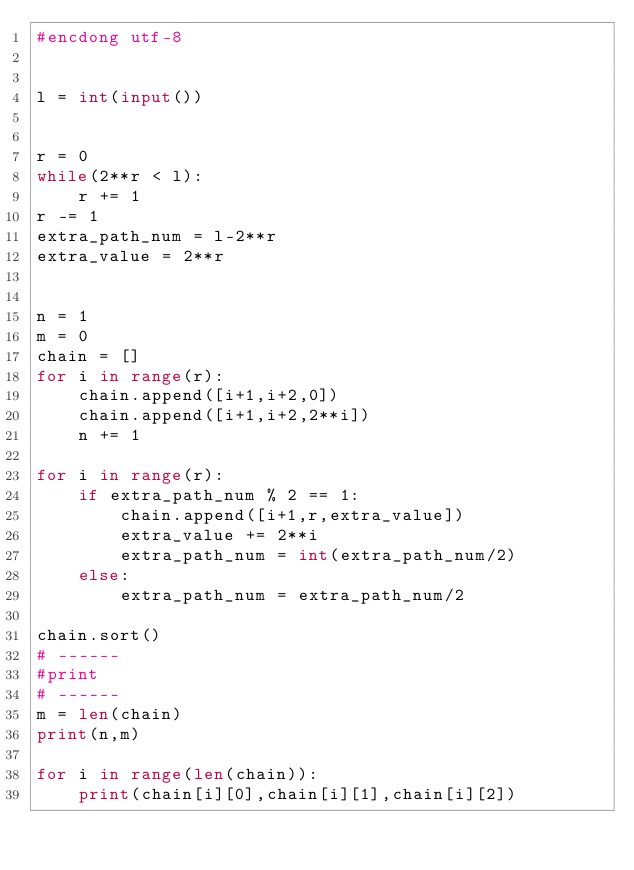Convert code to text. <code><loc_0><loc_0><loc_500><loc_500><_Python_>#encdong utf-8


l = int(input())


r = 0
while(2**r < l):
    r += 1
r -= 1
extra_path_num = l-2**r
extra_value = 2**r


n = 1
m = 0
chain = []
for i in range(r):
    chain.append([i+1,i+2,0])
    chain.append([i+1,i+2,2**i])
    n += 1

for i in range(r):
    if extra_path_num % 2 == 1:
        chain.append([i+1,r,extra_value])
        extra_value += 2**i
        extra_path_num = int(extra_path_num/2)
    else:
        extra_path_num = extra_path_num/2

chain.sort()
# ------
#print
# ------
m = len(chain)
print(n,m)

for i in range(len(chain)):
    print(chain[i][0],chain[i][1],chain[i][2])

    </code> 